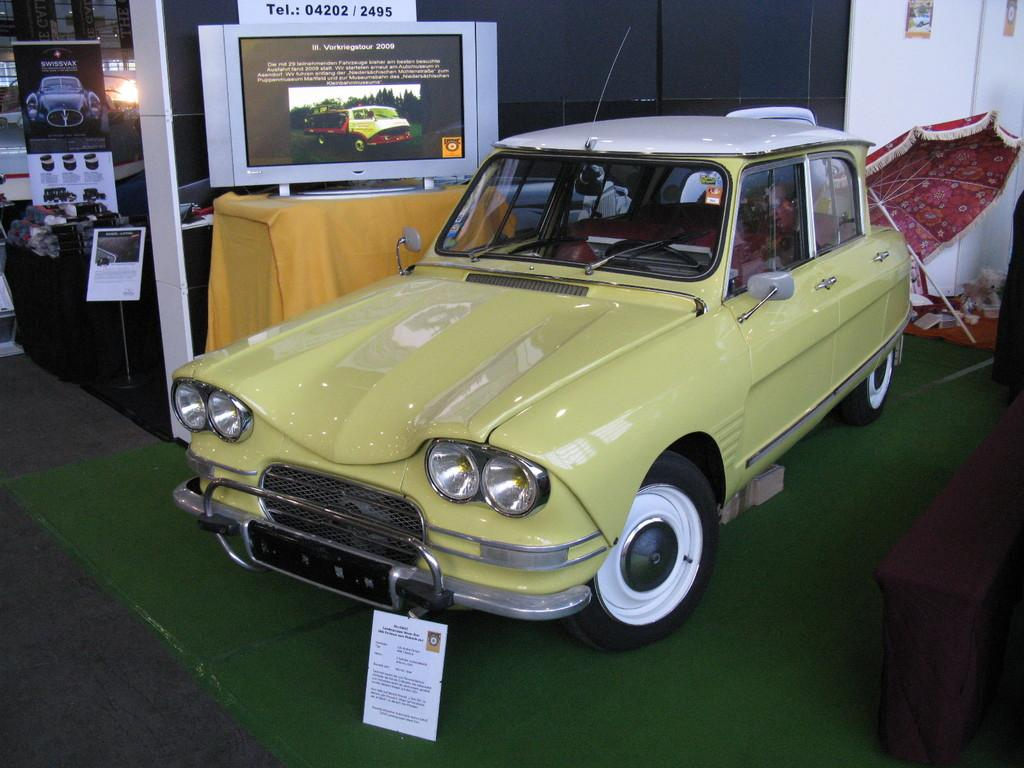What is parked on the floor in the image? There is a vehicle parked on the floor in the image. How is the vehicle covered? The vehicle is covered with a carpet. What can be seen near the vehicle? There is an umbrella near the vehicle. What is on the table in the image? There is a screen on a table. What is visible in the background of the image? The background contains other objects. Can you see the stranger's toes under the stocking in the image? There is no stranger or stocking present in the image, so it is not possible to see any toes. 